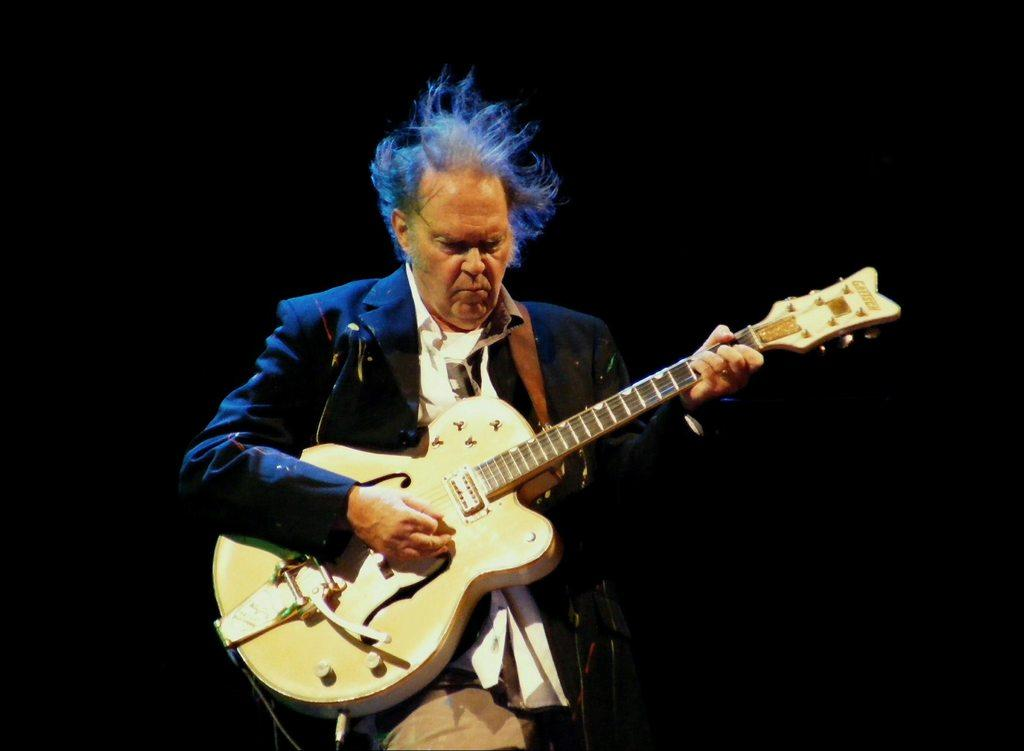What is the main subject of the image? There is a person in the image. What is the person holding in his hands? The person is holding a guitar in his hands. What type of vessel is the person using to perform magic in the image? There is no vessel or magic present in the image; the person is simply holding a guitar. 